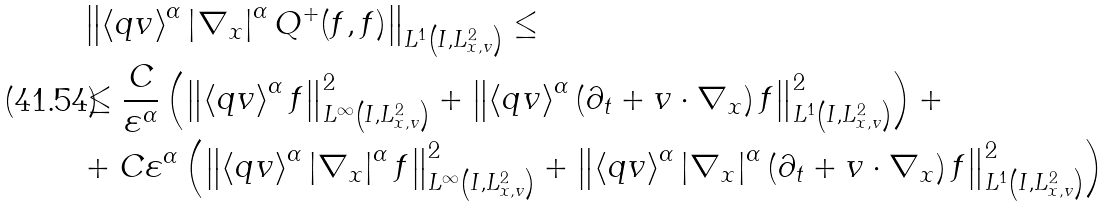Convert formula to latex. <formula><loc_0><loc_0><loc_500><loc_500>& \left \| \left < q v \right > ^ { \alpha } \left | \nabla _ { x } \right | ^ { \alpha } Q ^ { + } ( f , f ) \right \| _ { L ^ { 1 } \left ( I , L ^ { 2 } _ { x , v } \right ) } \leq \\ & \leq \frac { C } { \varepsilon ^ { \alpha } } \left ( \left \| \left < q v \right > ^ { \alpha } f \right \| ^ { 2 } _ { L ^ { \infty } \left ( I , L ^ { 2 } _ { x , v } \right ) } + \left \| \left < q v \right > ^ { \alpha } \left ( \partial _ { t } + v \cdot \nabla _ { x } \right ) f \right \| ^ { 2 } _ { L ^ { 1 } \left ( I , L ^ { 2 } _ { x , v } \right ) } \right ) + \\ & + C \varepsilon ^ { \alpha } \left ( \left \| \left < q v \right > ^ { \alpha } \left | \nabla _ { x } \right | ^ { \alpha } f \right \| ^ { 2 } _ { L ^ { \infty } \left ( I , L ^ { 2 } _ { x , v } \right ) } + \left \| \left < q v \right > ^ { \alpha } \left | \nabla _ { x } \right | ^ { \alpha } \left ( \partial _ { t } + v \cdot \nabla _ { x } \right ) f \right \| ^ { 2 } _ { L ^ { 1 } \left ( I , L ^ { 2 } _ { x , v } \right ) } \right ) \\</formula> 